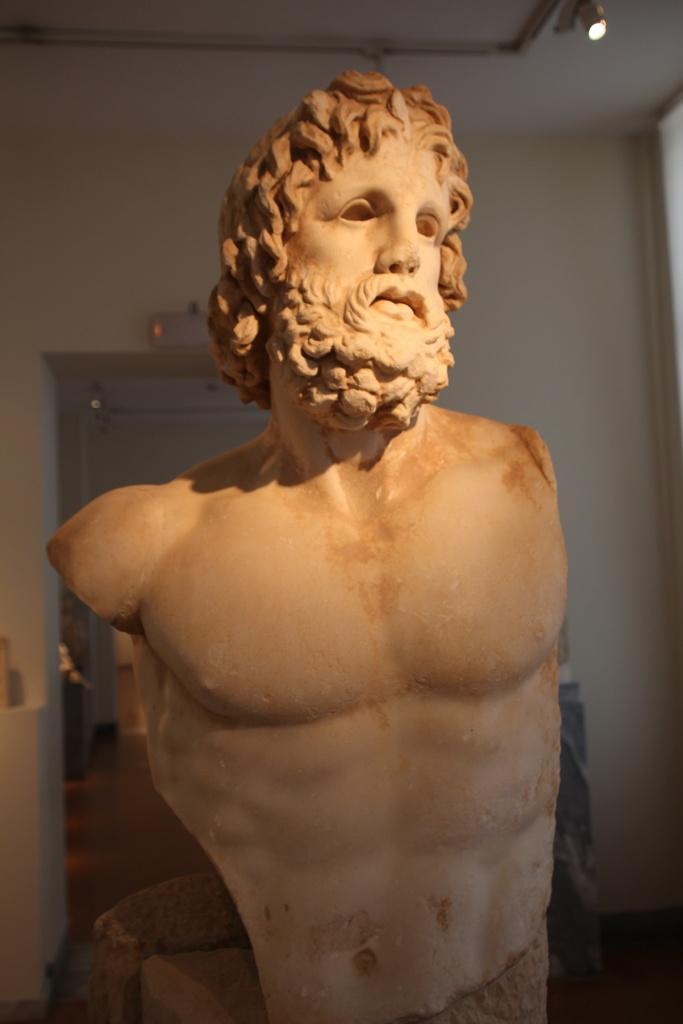In one or two sentences, can you explain what this image depicts? This picture shows stone carving of a man. we see light to the ceiling. 